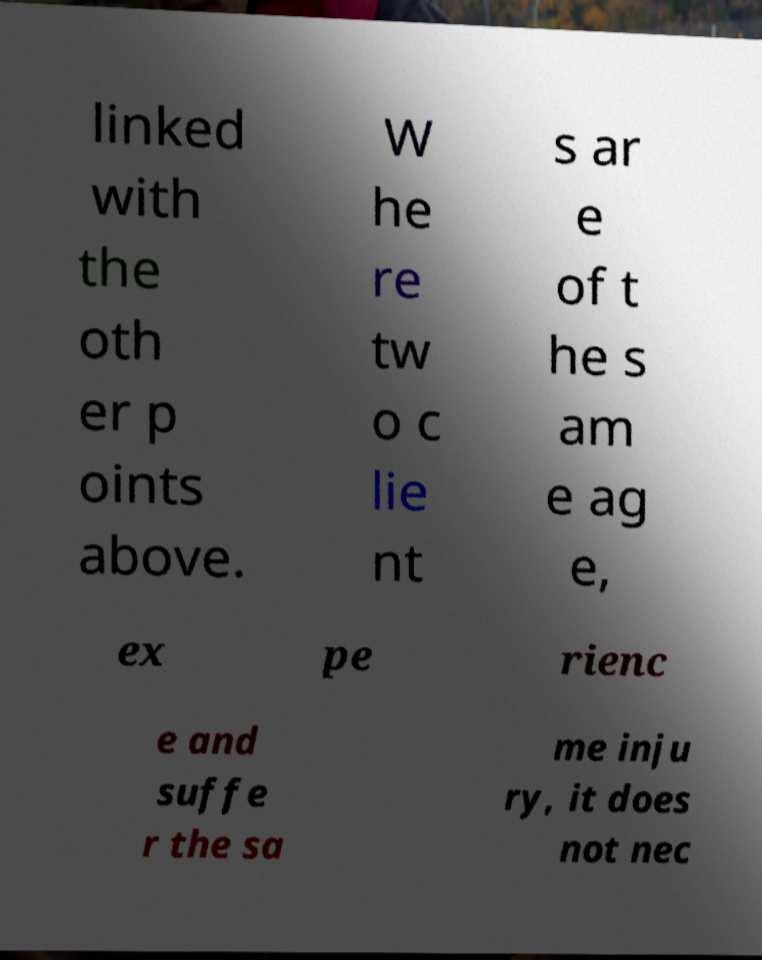Please identify and transcribe the text found in this image. linked with the oth er p oints above. W he re tw o c lie nt s ar e of t he s am e ag e, ex pe rienc e and suffe r the sa me inju ry, it does not nec 